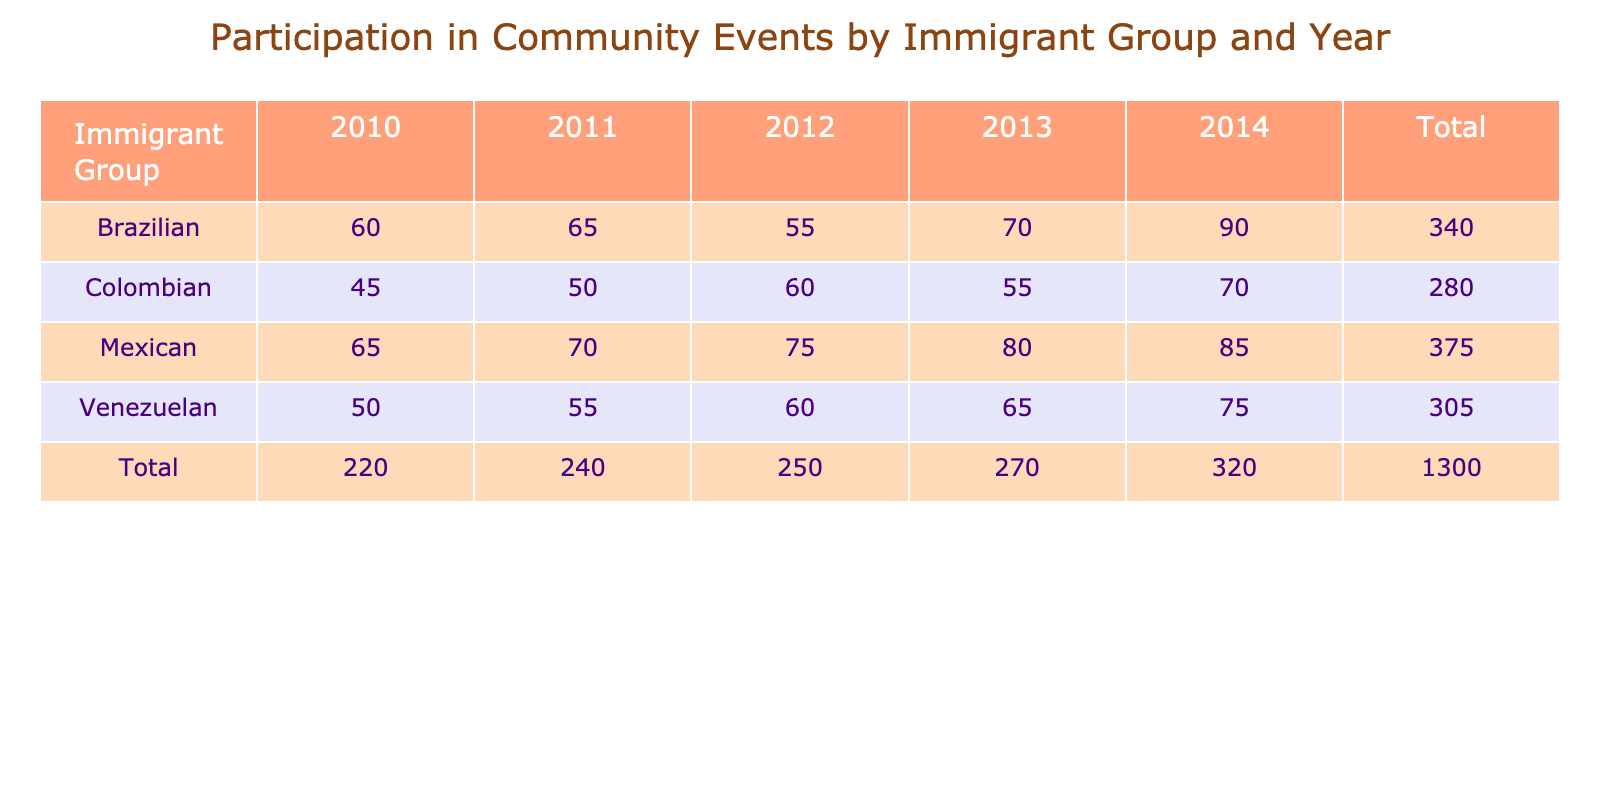What is the participation rate of Colombians in community events in 2014? The table indicates that the participation rate for Colombians in community events in 2014 is 70.
Answer: 70 What immigrant group had the highest participation rate in community events in 2013? By examining the table, we see that Mexican immigrants had a participation rate of 80 in 2013, which is higher than the other groups for that year.
Answer: Mexican What is the average participation rate for Venezuelans across all years? To find the average, we sum the participation rates for Venezuelans: (50 + 55 + 60 + 65 + 75) = 305. There are 5 data points, so the average is 305/5 = 61.
Answer: 61 Is the participation rate for Brazilians in 2012 higher than that for Colombians in the same year? From the table, Brazilians had a participation rate of 55 in 2012, while Colombians had a rate of 60. Therefore, no, Brazilian participation in 2012 is not higher than Colombian participation.
Answer: No What is the total participation rate in community events for Mexican immigrants from 2010 to 2014? To find the total, we add the participation rates for Mexicans: (65 + 70 + 75 + 80 + 85) = 375.
Answer: 375 Which immigrant group showed the most significant increase in participation from 2010 to 2014? For Colombians, the increase is 70 - 45 = 25. For Mexicans, it is 85 - 65 = 20. For Brazilians, it is 90 - 60 = 30. For Venezuelans, it is 75 - 50 = 25. Therefore, Brazilians had the highest increase of 30.
Answer: Brazilian How many community events did Venezuelans participate in during 2011 compared to Mexicans? Venezuelans participated in 55 events while Mexicans participated in 70 events in 2011. Hence, Venezuelans participated in fewer events than Mexicans.
Answer: No What was the total participation of all immigrant groups in 2010? Summing the participation rates for all groups in 2010 gives us: 45 (Colombians) + 65 (Mexicans) + 60 (Brazilians) + 50 (Venezuelans) = 220.
Answer: 220 Did any immigrant group have the same participation in 2013? Looking at the table, there are no two groups with the same participation rate in 2013; each group has a distinct rate: Colombians 55, Mexicans 80, Brazilians 70, and Venezuelans 65.
Answer: No 